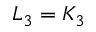<formula> <loc_0><loc_0><loc_500><loc_500>L _ { 3 } = K _ { 3 }</formula> 